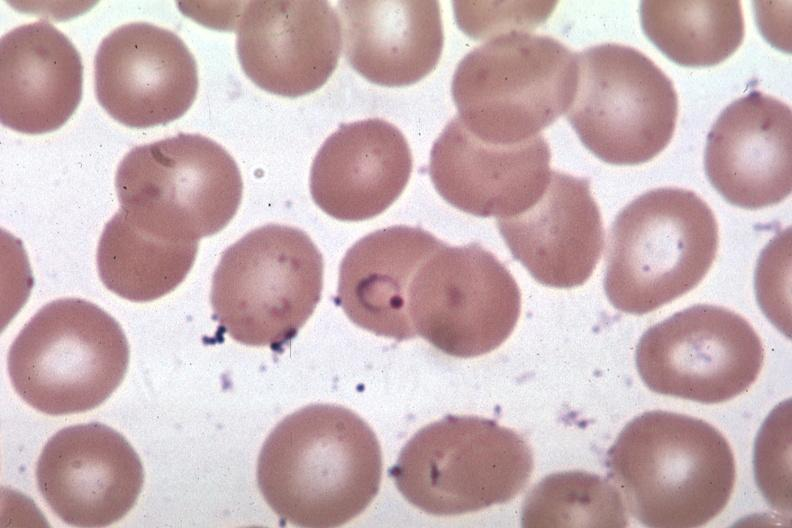s malaria plasmodium vivax present?
Answer the question using a single word or phrase. Yes 